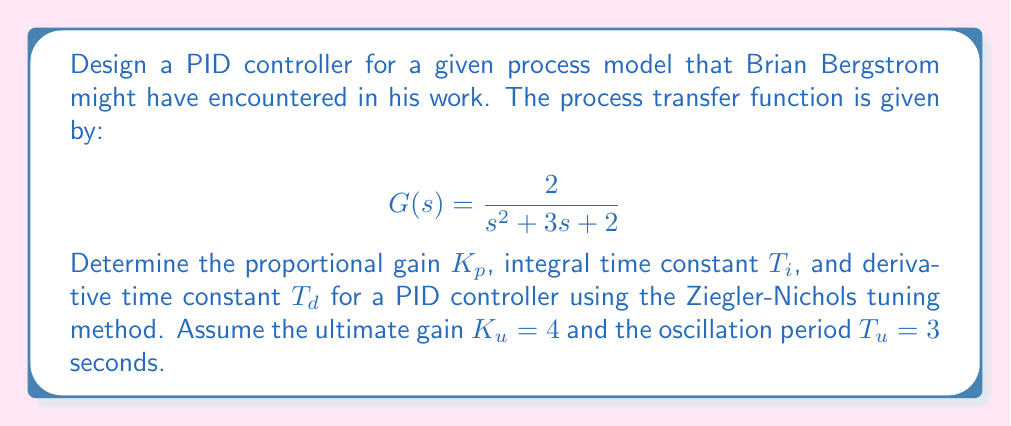Solve this math problem. To design a PID controller using the Ziegler-Nichols tuning method, we follow these steps:

1. We are given the ultimate gain $K_u = 4$ and the oscillation period $T_u = 3$ seconds.

2. For a PID controller, the Ziegler-Nichols tuning rules provide the following relationships:

   $K_p = 0.6K_u$
   $T_i = 0.5T_u$
   $T_d = 0.125T_u$

3. Calculate $K_p$:
   $K_p = 0.6 \times 4 = 2.4$

4. Calculate $T_i$:
   $T_i = 0.5 \times 3 = 1.5$ seconds

5. Calculate $T_d$:
   $T_d = 0.125 \times 3 = 0.375$ seconds

6. The PID controller transfer function is given by:

   $$C(s) = K_p(1 + \frac{1}{T_is} + T_ds)$$

   Substituting the calculated values:

   $$C(s) = 2.4(1 + \frac{1}{1.5s} + 0.375s)$$

This PID controller design should provide a good starting point for controlling the given process model. Brian Bergstrom would likely have needed to fine-tune these parameters based on the specific requirements of the system and performance criteria.
Answer: $K_p = 2.4$
$T_i = 1.5$ seconds
$T_d = 0.375$ seconds

PID controller transfer function:
$$C(s) = 2.4(1 + \frac{1}{1.5s} + 0.375s)$$ 